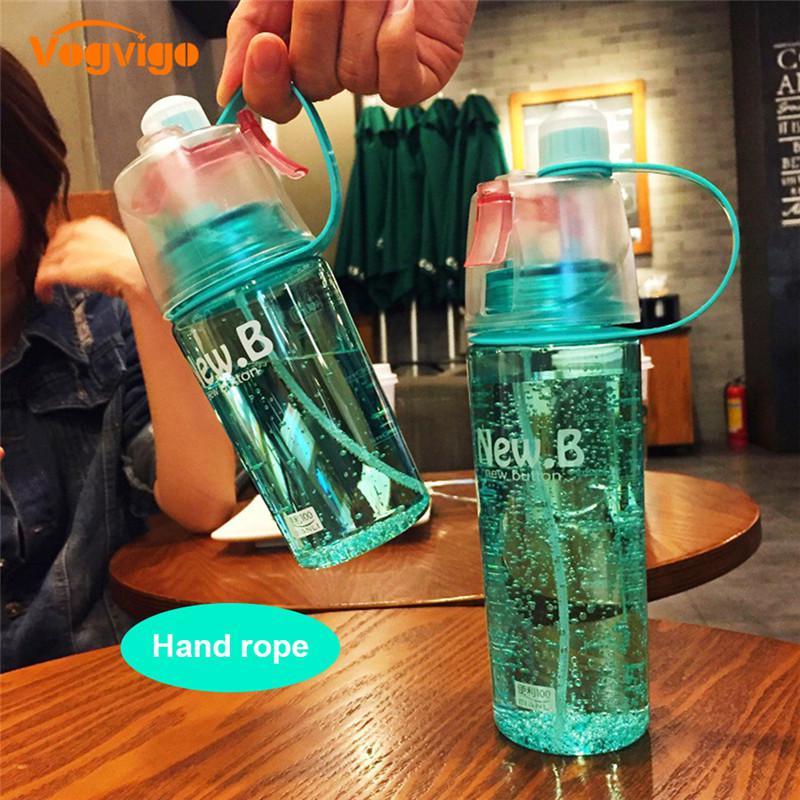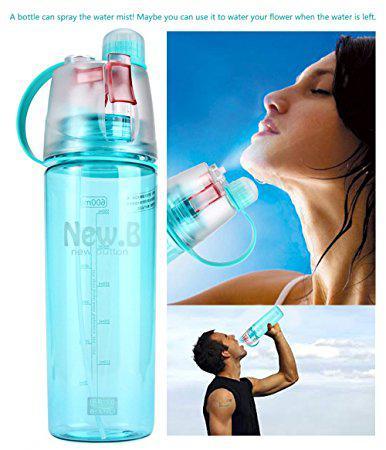The first image is the image on the left, the second image is the image on the right. Examine the images to the left and right. Is the description "The left image has three water bottles" accurate? Answer yes or no. No. 